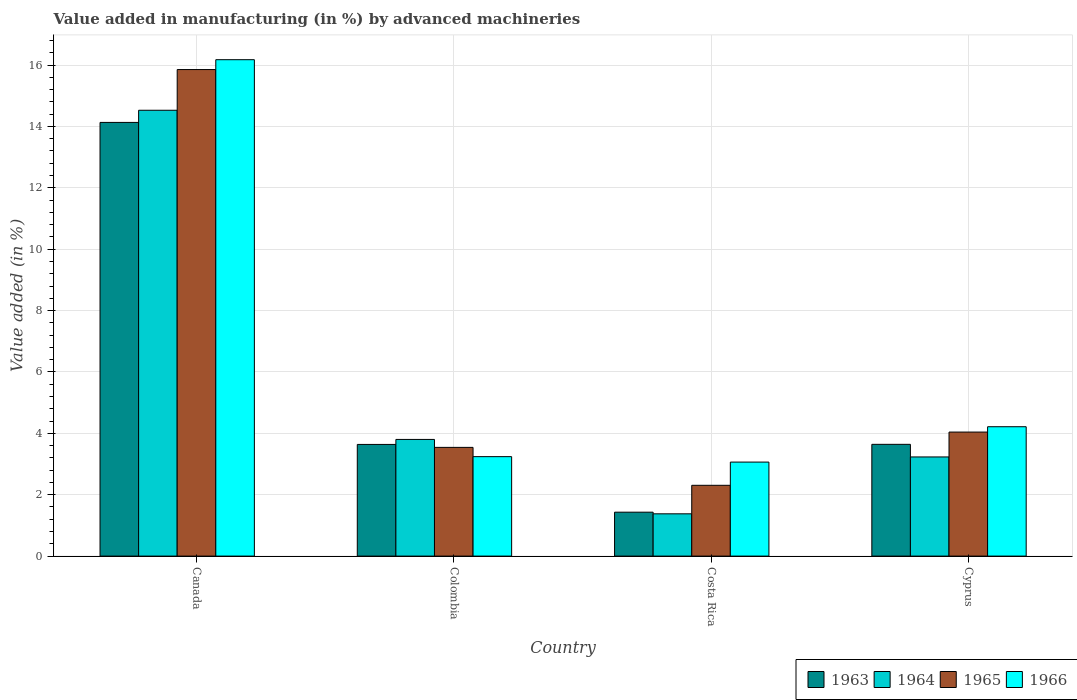How many different coloured bars are there?
Ensure brevity in your answer.  4. How many groups of bars are there?
Provide a short and direct response. 4. Are the number of bars per tick equal to the number of legend labels?
Provide a succinct answer. Yes. How many bars are there on the 3rd tick from the left?
Your answer should be compact. 4. How many bars are there on the 4th tick from the right?
Make the answer very short. 4. What is the percentage of value added in manufacturing by advanced machineries in 1964 in Colombia?
Keep it short and to the point. 3.8. Across all countries, what is the maximum percentage of value added in manufacturing by advanced machineries in 1966?
Keep it short and to the point. 16.17. Across all countries, what is the minimum percentage of value added in manufacturing by advanced machineries in 1965?
Offer a terse response. 2.31. In which country was the percentage of value added in manufacturing by advanced machineries in 1964 maximum?
Provide a short and direct response. Canada. In which country was the percentage of value added in manufacturing by advanced machineries in 1964 minimum?
Your response must be concise. Costa Rica. What is the total percentage of value added in manufacturing by advanced machineries in 1966 in the graph?
Offer a terse response. 26.69. What is the difference between the percentage of value added in manufacturing by advanced machineries in 1965 in Costa Rica and that in Cyprus?
Ensure brevity in your answer.  -1.73. What is the difference between the percentage of value added in manufacturing by advanced machineries in 1965 in Cyprus and the percentage of value added in manufacturing by advanced machineries in 1964 in Colombia?
Your answer should be compact. 0.24. What is the average percentage of value added in manufacturing by advanced machineries in 1966 per country?
Offer a terse response. 6.67. What is the difference between the percentage of value added in manufacturing by advanced machineries of/in 1964 and percentage of value added in manufacturing by advanced machineries of/in 1966 in Costa Rica?
Your response must be concise. -1.69. What is the ratio of the percentage of value added in manufacturing by advanced machineries in 1966 in Canada to that in Colombia?
Give a very brief answer. 4.99. What is the difference between the highest and the second highest percentage of value added in manufacturing by advanced machineries in 1966?
Your answer should be very brief. 12.93. What is the difference between the highest and the lowest percentage of value added in manufacturing by advanced machineries in 1965?
Make the answer very short. 13.55. In how many countries, is the percentage of value added in manufacturing by advanced machineries in 1964 greater than the average percentage of value added in manufacturing by advanced machineries in 1964 taken over all countries?
Make the answer very short. 1. Is the sum of the percentage of value added in manufacturing by advanced machineries in 1964 in Canada and Colombia greater than the maximum percentage of value added in manufacturing by advanced machineries in 1963 across all countries?
Your answer should be very brief. Yes. What does the 1st bar from the right in Cyprus represents?
Ensure brevity in your answer.  1966. Is it the case that in every country, the sum of the percentage of value added in manufacturing by advanced machineries in 1963 and percentage of value added in manufacturing by advanced machineries in 1966 is greater than the percentage of value added in manufacturing by advanced machineries in 1964?
Provide a succinct answer. Yes. How many bars are there?
Provide a short and direct response. 16. Are all the bars in the graph horizontal?
Provide a succinct answer. No. How many countries are there in the graph?
Keep it short and to the point. 4. Where does the legend appear in the graph?
Your response must be concise. Bottom right. What is the title of the graph?
Your response must be concise. Value added in manufacturing (in %) by advanced machineries. What is the label or title of the X-axis?
Offer a very short reply. Country. What is the label or title of the Y-axis?
Your answer should be compact. Value added (in %). What is the Value added (in %) of 1963 in Canada?
Provide a short and direct response. 14.13. What is the Value added (in %) in 1964 in Canada?
Ensure brevity in your answer.  14.53. What is the Value added (in %) of 1965 in Canada?
Offer a terse response. 15.85. What is the Value added (in %) of 1966 in Canada?
Provide a short and direct response. 16.17. What is the Value added (in %) in 1963 in Colombia?
Your response must be concise. 3.64. What is the Value added (in %) in 1964 in Colombia?
Give a very brief answer. 3.8. What is the Value added (in %) of 1965 in Colombia?
Ensure brevity in your answer.  3.54. What is the Value added (in %) of 1966 in Colombia?
Give a very brief answer. 3.24. What is the Value added (in %) of 1963 in Costa Rica?
Provide a short and direct response. 1.43. What is the Value added (in %) in 1964 in Costa Rica?
Offer a very short reply. 1.38. What is the Value added (in %) in 1965 in Costa Rica?
Your answer should be very brief. 2.31. What is the Value added (in %) in 1966 in Costa Rica?
Your response must be concise. 3.06. What is the Value added (in %) in 1963 in Cyprus?
Your answer should be compact. 3.64. What is the Value added (in %) in 1964 in Cyprus?
Offer a terse response. 3.23. What is the Value added (in %) in 1965 in Cyprus?
Ensure brevity in your answer.  4.04. What is the Value added (in %) in 1966 in Cyprus?
Give a very brief answer. 4.22. Across all countries, what is the maximum Value added (in %) of 1963?
Provide a succinct answer. 14.13. Across all countries, what is the maximum Value added (in %) in 1964?
Offer a very short reply. 14.53. Across all countries, what is the maximum Value added (in %) of 1965?
Provide a short and direct response. 15.85. Across all countries, what is the maximum Value added (in %) in 1966?
Provide a succinct answer. 16.17. Across all countries, what is the minimum Value added (in %) in 1963?
Your response must be concise. 1.43. Across all countries, what is the minimum Value added (in %) of 1964?
Ensure brevity in your answer.  1.38. Across all countries, what is the minimum Value added (in %) of 1965?
Your response must be concise. 2.31. Across all countries, what is the minimum Value added (in %) in 1966?
Ensure brevity in your answer.  3.06. What is the total Value added (in %) of 1963 in the graph?
Make the answer very short. 22.84. What is the total Value added (in %) in 1964 in the graph?
Give a very brief answer. 22.94. What is the total Value added (in %) of 1965 in the graph?
Make the answer very short. 25.74. What is the total Value added (in %) in 1966 in the graph?
Give a very brief answer. 26.69. What is the difference between the Value added (in %) of 1963 in Canada and that in Colombia?
Give a very brief answer. 10.49. What is the difference between the Value added (in %) of 1964 in Canada and that in Colombia?
Offer a terse response. 10.72. What is the difference between the Value added (in %) of 1965 in Canada and that in Colombia?
Your answer should be very brief. 12.31. What is the difference between the Value added (in %) of 1966 in Canada and that in Colombia?
Provide a short and direct response. 12.93. What is the difference between the Value added (in %) in 1963 in Canada and that in Costa Rica?
Your response must be concise. 12.7. What is the difference between the Value added (in %) of 1964 in Canada and that in Costa Rica?
Keep it short and to the point. 13.15. What is the difference between the Value added (in %) of 1965 in Canada and that in Costa Rica?
Provide a succinct answer. 13.55. What is the difference between the Value added (in %) in 1966 in Canada and that in Costa Rica?
Offer a terse response. 13.11. What is the difference between the Value added (in %) in 1963 in Canada and that in Cyprus?
Your answer should be very brief. 10.49. What is the difference between the Value added (in %) of 1964 in Canada and that in Cyprus?
Offer a very short reply. 11.3. What is the difference between the Value added (in %) in 1965 in Canada and that in Cyprus?
Provide a succinct answer. 11.81. What is the difference between the Value added (in %) of 1966 in Canada and that in Cyprus?
Your answer should be very brief. 11.96. What is the difference between the Value added (in %) in 1963 in Colombia and that in Costa Rica?
Make the answer very short. 2.21. What is the difference between the Value added (in %) of 1964 in Colombia and that in Costa Rica?
Provide a succinct answer. 2.42. What is the difference between the Value added (in %) in 1965 in Colombia and that in Costa Rica?
Your answer should be very brief. 1.24. What is the difference between the Value added (in %) in 1966 in Colombia and that in Costa Rica?
Ensure brevity in your answer.  0.18. What is the difference between the Value added (in %) of 1963 in Colombia and that in Cyprus?
Make the answer very short. -0. What is the difference between the Value added (in %) in 1964 in Colombia and that in Cyprus?
Give a very brief answer. 0.57. What is the difference between the Value added (in %) in 1965 in Colombia and that in Cyprus?
Keep it short and to the point. -0.5. What is the difference between the Value added (in %) of 1966 in Colombia and that in Cyprus?
Provide a short and direct response. -0.97. What is the difference between the Value added (in %) of 1963 in Costa Rica and that in Cyprus?
Your answer should be very brief. -2.21. What is the difference between the Value added (in %) of 1964 in Costa Rica and that in Cyprus?
Make the answer very short. -1.85. What is the difference between the Value added (in %) in 1965 in Costa Rica and that in Cyprus?
Your response must be concise. -1.73. What is the difference between the Value added (in %) in 1966 in Costa Rica and that in Cyprus?
Your response must be concise. -1.15. What is the difference between the Value added (in %) of 1963 in Canada and the Value added (in %) of 1964 in Colombia?
Offer a terse response. 10.33. What is the difference between the Value added (in %) in 1963 in Canada and the Value added (in %) in 1965 in Colombia?
Provide a succinct answer. 10.59. What is the difference between the Value added (in %) in 1963 in Canada and the Value added (in %) in 1966 in Colombia?
Your response must be concise. 10.89. What is the difference between the Value added (in %) of 1964 in Canada and the Value added (in %) of 1965 in Colombia?
Offer a very short reply. 10.98. What is the difference between the Value added (in %) in 1964 in Canada and the Value added (in %) in 1966 in Colombia?
Provide a short and direct response. 11.29. What is the difference between the Value added (in %) of 1965 in Canada and the Value added (in %) of 1966 in Colombia?
Provide a short and direct response. 12.61. What is the difference between the Value added (in %) of 1963 in Canada and the Value added (in %) of 1964 in Costa Rica?
Your answer should be very brief. 12.75. What is the difference between the Value added (in %) of 1963 in Canada and the Value added (in %) of 1965 in Costa Rica?
Your answer should be compact. 11.82. What is the difference between the Value added (in %) of 1963 in Canada and the Value added (in %) of 1966 in Costa Rica?
Give a very brief answer. 11.07. What is the difference between the Value added (in %) in 1964 in Canada and the Value added (in %) in 1965 in Costa Rica?
Keep it short and to the point. 12.22. What is the difference between the Value added (in %) of 1964 in Canada and the Value added (in %) of 1966 in Costa Rica?
Your response must be concise. 11.46. What is the difference between the Value added (in %) of 1965 in Canada and the Value added (in %) of 1966 in Costa Rica?
Offer a very short reply. 12.79. What is the difference between the Value added (in %) of 1963 in Canada and the Value added (in %) of 1964 in Cyprus?
Your response must be concise. 10.9. What is the difference between the Value added (in %) of 1963 in Canada and the Value added (in %) of 1965 in Cyprus?
Provide a short and direct response. 10.09. What is the difference between the Value added (in %) in 1963 in Canada and the Value added (in %) in 1966 in Cyprus?
Offer a very short reply. 9.92. What is the difference between the Value added (in %) of 1964 in Canada and the Value added (in %) of 1965 in Cyprus?
Your response must be concise. 10.49. What is the difference between the Value added (in %) in 1964 in Canada and the Value added (in %) in 1966 in Cyprus?
Your response must be concise. 10.31. What is the difference between the Value added (in %) of 1965 in Canada and the Value added (in %) of 1966 in Cyprus?
Your answer should be very brief. 11.64. What is the difference between the Value added (in %) in 1963 in Colombia and the Value added (in %) in 1964 in Costa Rica?
Your answer should be very brief. 2.26. What is the difference between the Value added (in %) of 1963 in Colombia and the Value added (in %) of 1965 in Costa Rica?
Your answer should be compact. 1.33. What is the difference between the Value added (in %) in 1963 in Colombia and the Value added (in %) in 1966 in Costa Rica?
Keep it short and to the point. 0.57. What is the difference between the Value added (in %) of 1964 in Colombia and the Value added (in %) of 1965 in Costa Rica?
Your response must be concise. 1.49. What is the difference between the Value added (in %) in 1964 in Colombia and the Value added (in %) in 1966 in Costa Rica?
Make the answer very short. 0.74. What is the difference between the Value added (in %) in 1965 in Colombia and the Value added (in %) in 1966 in Costa Rica?
Make the answer very short. 0.48. What is the difference between the Value added (in %) of 1963 in Colombia and the Value added (in %) of 1964 in Cyprus?
Provide a succinct answer. 0.41. What is the difference between the Value added (in %) in 1963 in Colombia and the Value added (in %) in 1965 in Cyprus?
Make the answer very short. -0.4. What is the difference between the Value added (in %) of 1963 in Colombia and the Value added (in %) of 1966 in Cyprus?
Give a very brief answer. -0.58. What is the difference between the Value added (in %) of 1964 in Colombia and the Value added (in %) of 1965 in Cyprus?
Offer a very short reply. -0.24. What is the difference between the Value added (in %) of 1964 in Colombia and the Value added (in %) of 1966 in Cyprus?
Your answer should be compact. -0.41. What is the difference between the Value added (in %) of 1965 in Colombia and the Value added (in %) of 1966 in Cyprus?
Provide a short and direct response. -0.67. What is the difference between the Value added (in %) of 1963 in Costa Rica and the Value added (in %) of 1964 in Cyprus?
Ensure brevity in your answer.  -1.8. What is the difference between the Value added (in %) in 1963 in Costa Rica and the Value added (in %) in 1965 in Cyprus?
Offer a terse response. -2.61. What is the difference between the Value added (in %) in 1963 in Costa Rica and the Value added (in %) in 1966 in Cyprus?
Provide a short and direct response. -2.78. What is the difference between the Value added (in %) of 1964 in Costa Rica and the Value added (in %) of 1965 in Cyprus?
Ensure brevity in your answer.  -2.66. What is the difference between the Value added (in %) of 1964 in Costa Rica and the Value added (in %) of 1966 in Cyprus?
Provide a succinct answer. -2.84. What is the difference between the Value added (in %) of 1965 in Costa Rica and the Value added (in %) of 1966 in Cyprus?
Offer a terse response. -1.91. What is the average Value added (in %) in 1963 per country?
Make the answer very short. 5.71. What is the average Value added (in %) of 1964 per country?
Give a very brief answer. 5.73. What is the average Value added (in %) in 1965 per country?
Ensure brevity in your answer.  6.44. What is the average Value added (in %) in 1966 per country?
Offer a very short reply. 6.67. What is the difference between the Value added (in %) of 1963 and Value added (in %) of 1964 in Canada?
Offer a terse response. -0.4. What is the difference between the Value added (in %) in 1963 and Value added (in %) in 1965 in Canada?
Keep it short and to the point. -1.72. What is the difference between the Value added (in %) in 1963 and Value added (in %) in 1966 in Canada?
Offer a terse response. -2.04. What is the difference between the Value added (in %) of 1964 and Value added (in %) of 1965 in Canada?
Make the answer very short. -1.33. What is the difference between the Value added (in %) in 1964 and Value added (in %) in 1966 in Canada?
Ensure brevity in your answer.  -1.65. What is the difference between the Value added (in %) in 1965 and Value added (in %) in 1966 in Canada?
Ensure brevity in your answer.  -0.32. What is the difference between the Value added (in %) of 1963 and Value added (in %) of 1964 in Colombia?
Offer a very short reply. -0.16. What is the difference between the Value added (in %) in 1963 and Value added (in %) in 1965 in Colombia?
Provide a short and direct response. 0.1. What is the difference between the Value added (in %) in 1963 and Value added (in %) in 1966 in Colombia?
Ensure brevity in your answer.  0.4. What is the difference between the Value added (in %) of 1964 and Value added (in %) of 1965 in Colombia?
Your answer should be very brief. 0.26. What is the difference between the Value added (in %) of 1964 and Value added (in %) of 1966 in Colombia?
Provide a short and direct response. 0.56. What is the difference between the Value added (in %) of 1965 and Value added (in %) of 1966 in Colombia?
Provide a succinct answer. 0.3. What is the difference between the Value added (in %) in 1963 and Value added (in %) in 1964 in Costa Rica?
Your answer should be compact. 0.05. What is the difference between the Value added (in %) in 1963 and Value added (in %) in 1965 in Costa Rica?
Your answer should be very brief. -0.88. What is the difference between the Value added (in %) in 1963 and Value added (in %) in 1966 in Costa Rica?
Give a very brief answer. -1.63. What is the difference between the Value added (in %) in 1964 and Value added (in %) in 1965 in Costa Rica?
Your answer should be compact. -0.93. What is the difference between the Value added (in %) of 1964 and Value added (in %) of 1966 in Costa Rica?
Offer a very short reply. -1.69. What is the difference between the Value added (in %) in 1965 and Value added (in %) in 1966 in Costa Rica?
Provide a succinct answer. -0.76. What is the difference between the Value added (in %) of 1963 and Value added (in %) of 1964 in Cyprus?
Provide a short and direct response. 0.41. What is the difference between the Value added (in %) in 1963 and Value added (in %) in 1965 in Cyprus?
Give a very brief answer. -0.4. What is the difference between the Value added (in %) of 1963 and Value added (in %) of 1966 in Cyprus?
Give a very brief answer. -0.57. What is the difference between the Value added (in %) in 1964 and Value added (in %) in 1965 in Cyprus?
Your response must be concise. -0.81. What is the difference between the Value added (in %) in 1964 and Value added (in %) in 1966 in Cyprus?
Ensure brevity in your answer.  -0.98. What is the difference between the Value added (in %) in 1965 and Value added (in %) in 1966 in Cyprus?
Offer a very short reply. -0.17. What is the ratio of the Value added (in %) of 1963 in Canada to that in Colombia?
Your answer should be compact. 3.88. What is the ratio of the Value added (in %) of 1964 in Canada to that in Colombia?
Provide a succinct answer. 3.82. What is the ratio of the Value added (in %) in 1965 in Canada to that in Colombia?
Ensure brevity in your answer.  4.48. What is the ratio of the Value added (in %) of 1966 in Canada to that in Colombia?
Provide a succinct answer. 4.99. What is the ratio of the Value added (in %) in 1963 in Canada to that in Costa Rica?
Make the answer very short. 9.87. What is the ratio of the Value added (in %) of 1964 in Canada to that in Costa Rica?
Provide a short and direct response. 10.54. What is the ratio of the Value added (in %) of 1965 in Canada to that in Costa Rica?
Provide a short and direct response. 6.87. What is the ratio of the Value added (in %) in 1966 in Canada to that in Costa Rica?
Keep it short and to the point. 5.28. What is the ratio of the Value added (in %) of 1963 in Canada to that in Cyprus?
Give a very brief answer. 3.88. What is the ratio of the Value added (in %) of 1964 in Canada to that in Cyprus?
Provide a short and direct response. 4.5. What is the ratio of the Value added (in %) in 1965 in Canada to that in Cyprus?
Offer a terse response. 3.92. What is the ratio of the Value added (in %) in 1966 in Canada to that in Cyprus?
Offer a very short reply. 3.84. What is the ratio of the Value added (in %) of 1963 in Colombia to that in Costa Rica?
Your answer should be very brief. 2.54. What is the ratio of the Value added (in %) in 1964 in Colombia to that in Costa Rica?
Your answer should be very brief. 2.76. What is the ratio of the Value added (in %) of 1965 in Colombia to that in Costa Rica?
Keep it short and to the point. 1.54. What is the ratio of the Value added (in %) of 1966 in Colombia to that in Costa Rica?
Your answer should be very brief. 1.06. What is the ratio of the Value added (in %) of 1963 in Colombia to that in Cyprus?
Offer a terse response. 1. What is the ratio of the Value added (in %) in 1964 in Colombia to that in Cyprus?
Ensure brevity in your answer.  1.18. What is the ratio of the Value added (in %) in 1965 in Colombia to that in Cyprus?
Your response must be concise. 0.88. What is the ratio of the Value added (in %) in 1966 in Colombia to that in Cyprus?
Give a very brief answer. 0.77. What is the ratio of the Value added (in %) in 1963 in Costa Rica to that in Cyprus?
Make the answer very short. 0.39. What is the ratio of the Value added (in %) of 1964 in Costa Rica to that in Cyprus?
Provide a short and direct response. 0.43. What is the ratio of the Value added (in %) of 1965 in Costa Rica to that in Cyprus?
Offer a very short reply. 0.57. What is the ratio of the Value added (in %) in 1966 in Costa Rica to that in Cyprus?
Your response must be concise. 0.73. What is the difference between the highest and the second highest Value added (in %) of 1963?
Your response must be concise. 10.49. What is the difference between the highest and the second highest Value added (in %) in 1964?
Your answer should be compact. 10.72. What is the difference between the highest and the second highest Value added (in %) of 1965?
Give a very brief answer. 11.81. What is the difference between the highest and the second highest Value added (in %) of 1966?
Give a very brief answer. 11.96. What is the difference between the highest and the lowest Value added (in %) in 1963?
Provide a succinct answer. 12.7. What is the difference between the highest and the lowest Value added (in %) of 1964?
Your answer should be very brief. 13.15. What is the difference between the highest and the lowest Value added (in %) in 1965?
Offer a very short reply. 13.55. What is the difference between the highest and the lowest Value added (in %) of 1966?
Provide a short and direct response. 13.11. 